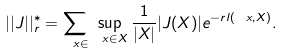Convert formula to latex. <formula><loc_0><loc_0><loc_500><loc_500>| | J | | _ { r } ^ { * } = \sum _ { \ x \in \L } \sup _ { \ x \in X } \frac { 1 } { | X | } | J ( X ) | e ^ { - r l ( \ x , X ) } .</formula> 